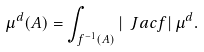<formula> <loc_0><loc_0><loc_500><loc_500>\mu ^ { d } ( A ) = \int _ { f ^ { - 1 } ( A ) } | \ J a c f | \, \mu ^ { d } .</formula> 